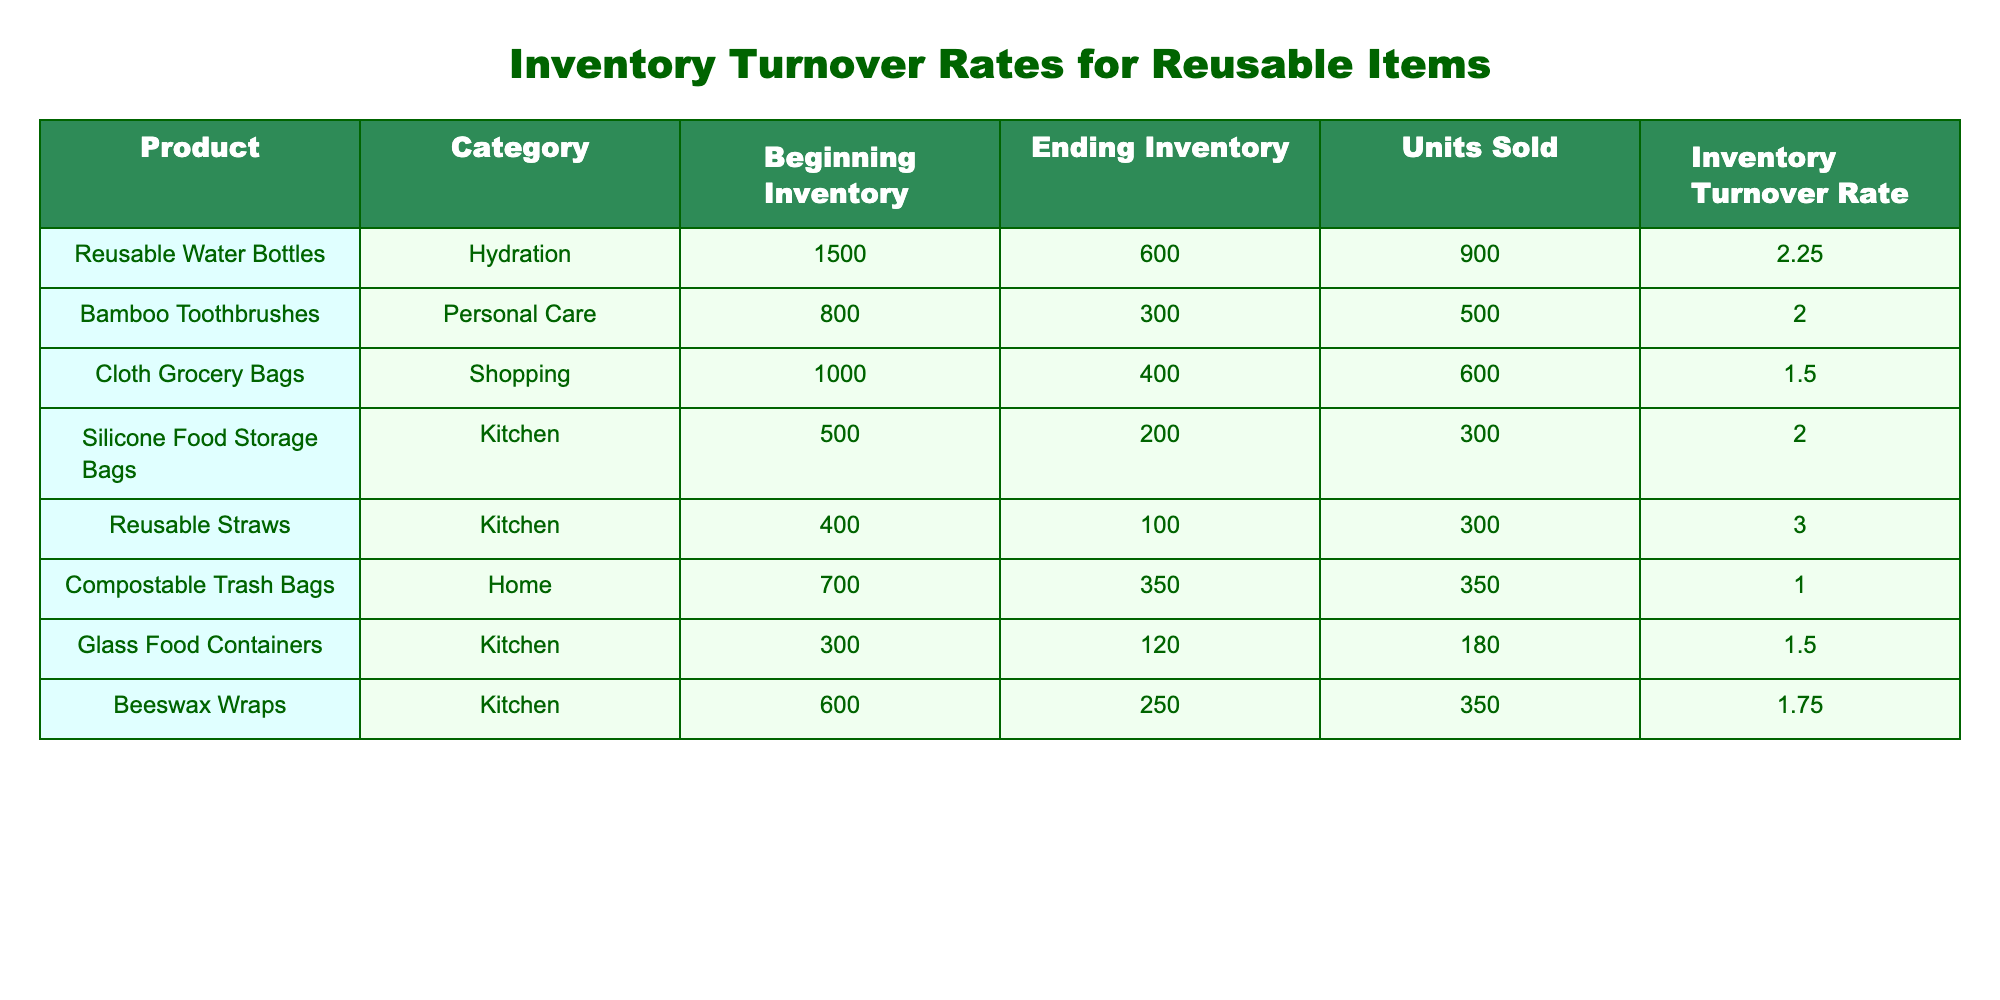What is the Inventory Turnover Rate for Reusable Water Bottles? The table shows the Inventory Turnover Rate for Reusable Water Bottles as 2.25. This value is clearly stated in the corresponding row of the table.
Answer: 2.25 Which product category has the highest Inventory Turnover Rate? By reviewing the Inventory Turnover Rates listed in the table, the Reusable Straws in the Kitchen category has the highest rate at 3.00.
Answer: Kitchen How many units of Compostable Trash Bags were sold? The Units Sold column indicates that 350 units of Compostable Trash Bags were sold, as stated in the respective row of the table.
Answer: 350 What is the average Inventory Turnover Rate for all products listed? To find the average, we sum up the Inventory Turnover Rates (2.25 + 2.00 + 1.50 + 2.00 + 3.00 + 1.00 + 1.50 + 1.75) which equals 13.00. Then, dividing by the number of products (8) gives us an average of 1.625.
Answer: 1.625 Did any product have an Ending Inventory lower than its Beginning Inventory? Yes, all listed products had a lower Ending Inventory than their Beginning Inventory, as we can see that each Ending Inventory value is less than the corresponding Beginning Inventory value in the table.
Answer: Yes Which product had the lowest amount sold? By checking the Units Sold column, the product with the lowest amount sold is the Glass Food Containers, with 180 units sold.
Answer: Glass Food Containers What is the difference between the Ending Inventory of Bamboo Toothbrushes and the ending inventory of Silicone Food Storage Bags? The Ending Inventory of Bamboo Toothbrushes is 300 and that of Silicone Food Storage Bags is 200. The difference is calculated as 300 - 200 = 100.
Answer: 100 How many total units were sold for Kitchen category products? The total units sold in the Kitchen category can be calculated by adding up the Units Sold for the two relevant products: Silicone Food Storage Bags (300) + Reusable Straws (300) + Glass Food Containers (180) + Beeswax Wraps (350). This gives us a total of 1130 units sold.
Answer: 1130 For which product was the Inventory Turnover Rate closest to 1? The Inventory Turnover Rate closest to 1 is for Compostable Trash Bags, which is exactly 1.00. This can be identified by comparing the values in the Inventory Turnover Rate column.
Answer: Compostable Trash Bags 